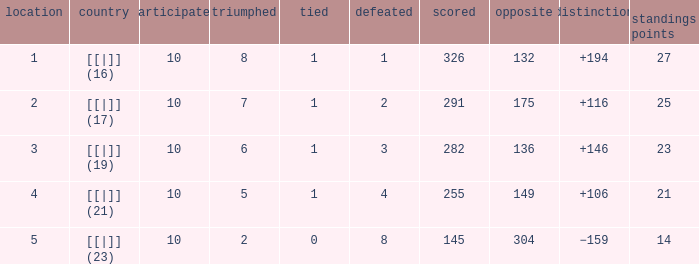 How many games had a deficit of 175?  1.0. 